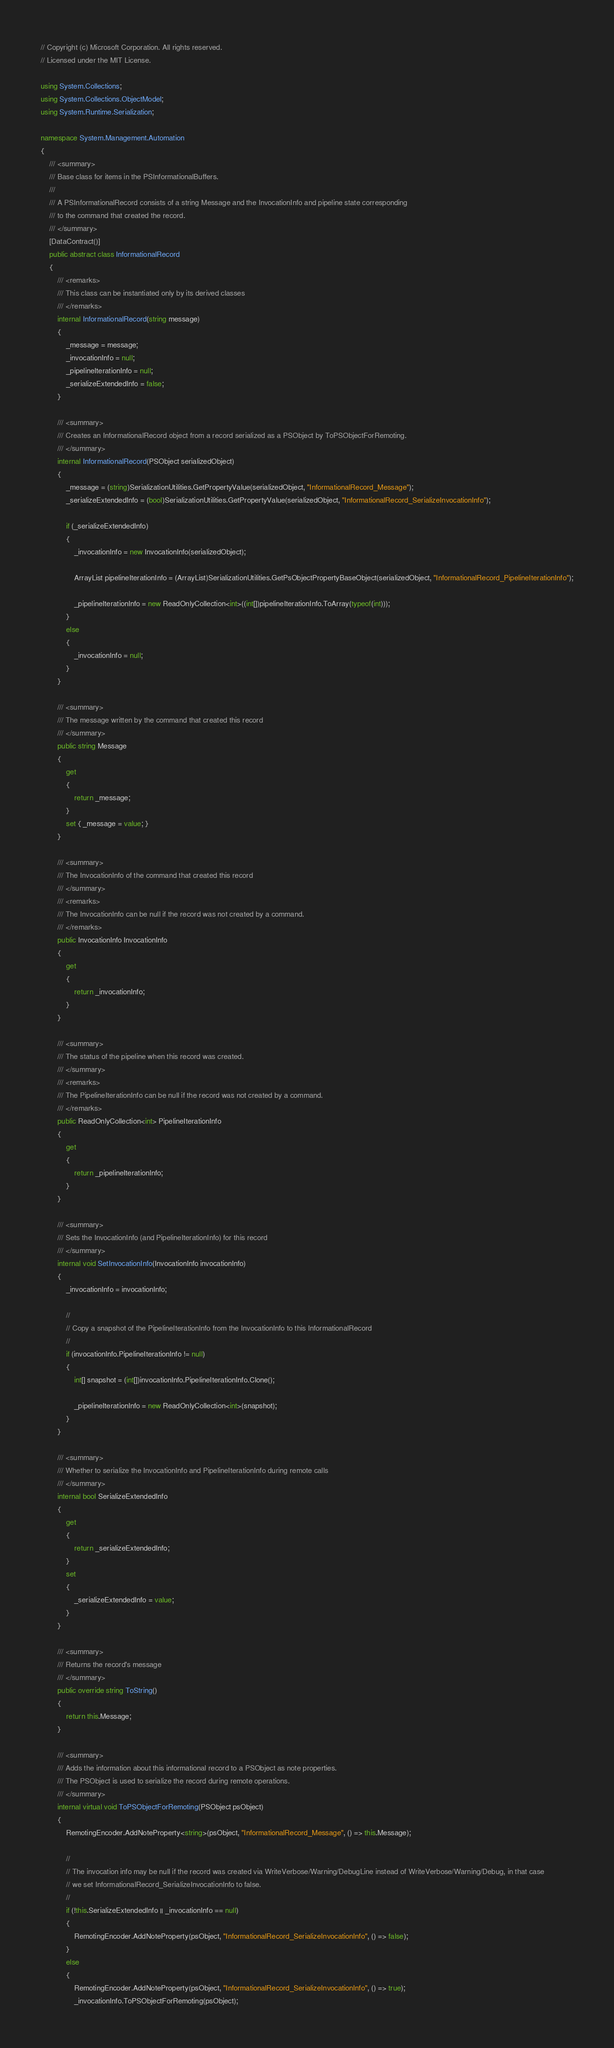<code> <loc_0><loc_0><loc_500><loc_500><_C#_>// Copyright (c) Microsoft Corporation. All rights reserved.
// Licensed under the MIT License.

using System.Collections;
using System.Collections.ObjectModel;
using System.Runtime.Serialization;

namespace System.Management.Automation
{
    /// <summary>
    /// Base class for items in the PSInformationalBuffers.
    ///
    /// A PSInformationalRecord consists of a string Message and the InvocationInfo and pipeline state corresponding
    /// to the command that created the record.
    /// </summary>
    [DataContract()]
    public abstract class InformationalRecord
    {
        /// <remarks>
        /// This class can be instantiated only by its derived classes
        /// </remarks>
        internal InformationalRecord(string message)
        {
            _message = message;
            _invocationInfo = null;
            _pipelineIterationInfo = null;
            _serializeExtendedInfo = false;
        }

        /// <summary>
        /// Creates an InformationalRecord object from a record serialized as a PSObject by ToPSObjectForRemoting.
        /// </summary>
        internal InformationalRecord(PSObject serializedObject)
        {
            _message = (string)SerializationUtilities.GetPropertyValue(serializedObject, "InformationalRecord_Message");
            _serializeExtendedInfo = (bool)SerializationUtilities.GetPropertyValue(serializedObject, "InformationalRecord_SerializeInvocationInfo");

            if (_serializeExtendedInfo)
            {
                _invocationInfo = new InvocationInfo(serializedObject);

                ArrayList pipelineIterationInfo = (ArrayList)SerializationUtilities.GetPsObjectPropertyBaseObject(serializedObject, "InformationalRecord_PipelineIterationInfo");

                _pipelineIterationInfo = new ReadOnlyCollection<int>((int[])pipelineIterationInfo.ToArray(typeof(int)));
            }
            else
            {
                _invocationInfo = null;
            }
        }

        /// <summary>
        /// The message written by the command that created this record
        /// </summary>
        public string Message
        {
            get
            {
                return _message;
            }
            set { _message = value; }
        }

        /// <summary>
        /// The InvocationInfo of the command that created this record
        /// </summary>
        /// <remarks>
        /// The InvocationInfo can be null if the record was not created by a command.
        /// </remarks>
        public InvocationInfo InvocationInfo
        {
            get
            {
                return _invocationInfo;
            }
        }

        /// <summary>
        /// The status of the pipeline when this record was created.
        /// </summary>
        /// <remarks>
        /// The PipelineIterationInfo can be null if the record was not created by a command.
        /// </remarks>
        public ReadOnlyCollection<int> PipelineIterationInfo
        {
            get
            {
                return _pipelineIterationInfo;
            }
        }

        /// <summary>
        /// Sets the InvocationInfo (and PipelineIterationInfo) for this record
        /// </summary>
        internal void SetInvocationInfo(InvocationInfo invocationInfo)
        {
            _invocationInfo = invocationInfo;

            //
            // Copy a snapshot of the PipelineIterationInfo from the InvocationInfo to this InformationalRecord
            //
            if (invocationInfo.PipelineIterationInfo != null)
            {
                int[] snapshot = (int[])invocationInfo.PipelineIterationInfo.Clone();

                _pipelineIterationInfo = new ReadOnlyCollection<int>(snapshot);
            }
        }

        /// <summary>
        /// Whether to serialize the InvocationInfo and PipelineIterationInfo during remote calls
        /// </summary>
        internal bool SerializeExtendedInfo
        {
            get
            {
                return _serializeExtendedInfo;
            }
            set
            {
                _serializeExtendedInfo = value;
            }
        }

        /// <summary>
        /// Returns the record's message
        /// </summary>
        public override string ToString()
        {
            return this.Message;
        }

        /// <summary>
        /// Adds the information about this informational record to a PSObject as note properties.
        /// The PSObject is used to serialize the record during remote operations.
        /// </summary>
        internal virtual void ToPSObjectForRemoting(PSObject psObject)
        {
            RemotingEncoder.AddNoteProperty<string>(psObject, "InformationalRecord_Message", () => this.Message);

            //
            // The invocation info may be null if the record was created via WriteVerbose/Warning/DebugLine instead of WriteVerbose/Warning/Debug, in that case
            // we set InformationalRecord_SerializeInvocationInfo to false.
            //
            if (!this.SerializeExtendedInfo || _invocationInfo == null)
            {
                RemotingEncoder.AddNoteProperty(psObject, "InformationalRecord_SerializeInvocationInfo", () => false);
            }
            else
            {
                RemotingEncoder.AddNoteProperty(psObject, "InformationalRecord_SerializeInvocationInfo", () => true);
                _invocationInfo.ToPSObjectForRemoting(psObject);</code> 